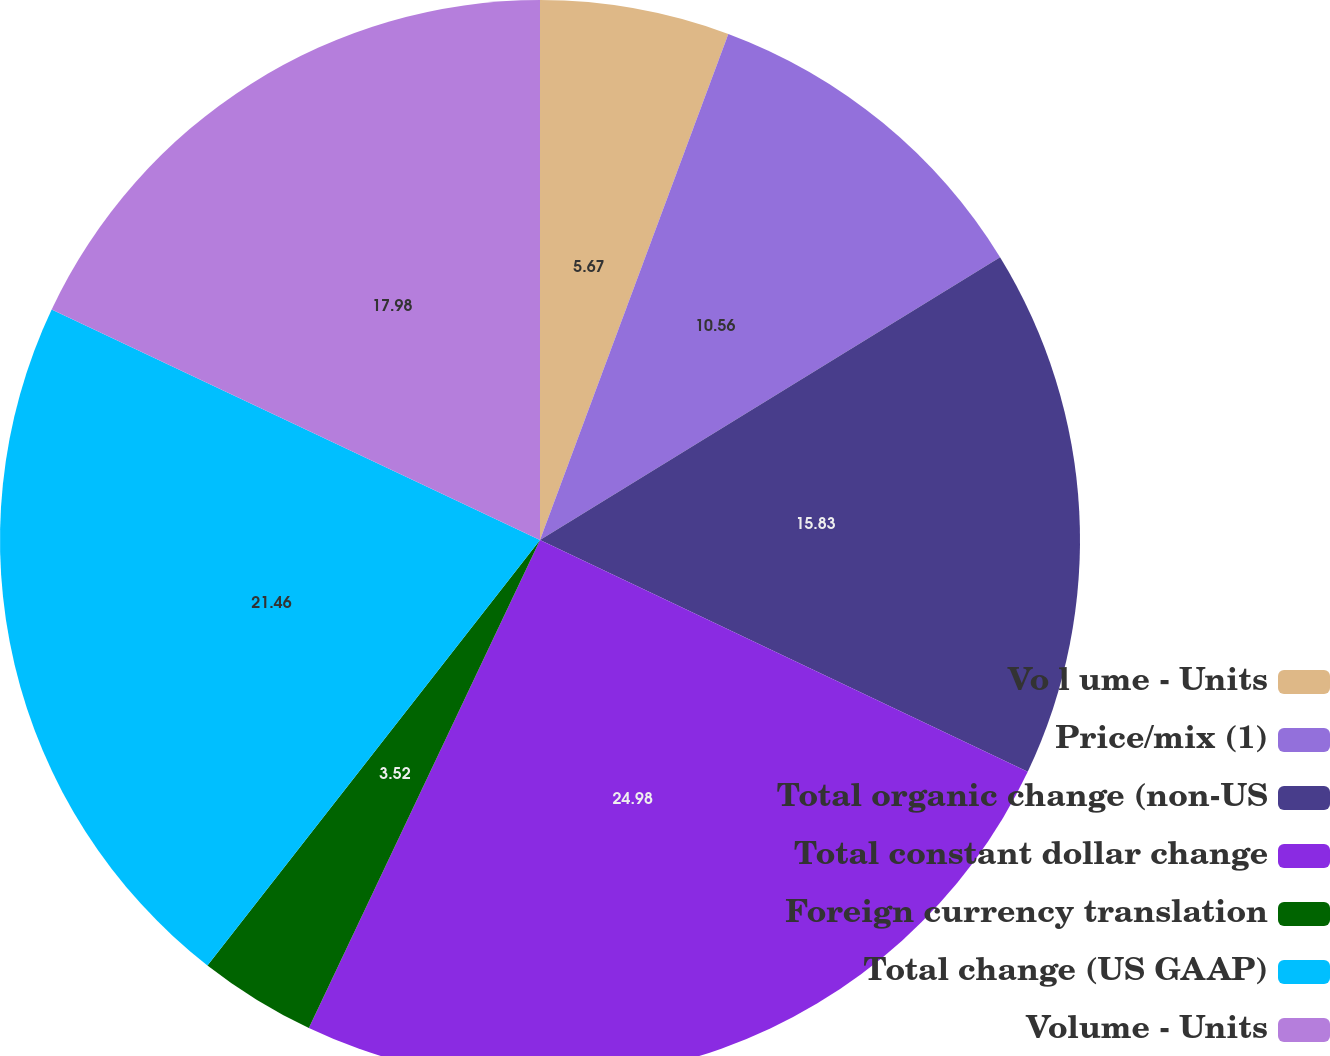Convert chart to OTSL. <chart><loc_0><loc_0><loc_500><loc_500><pie_chart><fcel>Vo l ume - Units<fcel>Price/mix (1)<fcel>Total organic change (non-US<fcel>Total constant dollar change<fcel>Foreign currency translation<fcel>Total change (US GAAP)<fcel>Volume - Units<nl><fcel>5.67%<fcel>10.56%<fcel>15.83%<fcel>24.98%<fcel>3.52%<fcel>21.46%<fcel>17.98%<nl></chart> 